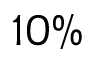Convert formula to latex. <formula><loc_0><loc_0><loc_500><loc_500>1 0 \%</formula> 